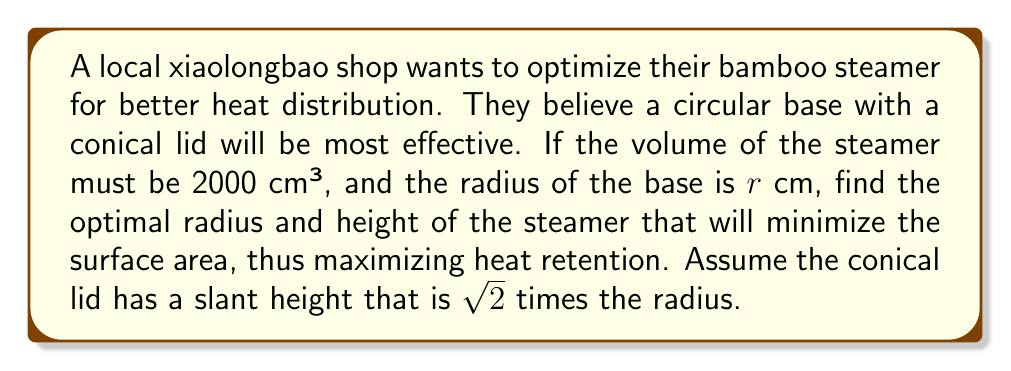Provide a solution to this math problem. Let's approach this step-by-step:

1) Let's define our variables:
   $r$ = radius of the base (and top of cone)
   $h$ = height of the cylindrical part
   $H$ = height of the cone

2) The volume of the steamer is the sum of the cylinder and cone volumes:
   $$V = \pi r^2 h + \frac{1}{3}\pi r^2 H = 2000$$

3) We're told the slant height of the cone is $\sqrt{2}r$. Using the Pythagorean theorem:
   $$r^2 + H^2 = 2r^2$$
   $$H = r$$

4) Substituting this into our volume equation:
   $$\pi r^2 h + \frac{1}{3}\pi r^3 = 2000$$
   $$\pi r^2 (h + \frac{1}{3}r) = 2000$$
   $$h = \frac{2000}{\pi r^2} - \frac{1}{3}r$$

5) The surface area (SA) of the steamer is the sum of the circular base, cylindrical side, and conical surface:
   $$SA = \pi r^2 + 2\pi rh + \pi r\sqrt{2}r$$
   
   Substituting $h$:
   $$SA = \pi r^2 + 2\pi r(\frac{2000}{\pi r^2} - \frac{1}{3}r) + \sqrt{2}\pi r^2$$
   $$SA = \pi r^2 + \frac{4000}{r} - \frac{2}{3}\pi r^2 + \sqrt{2}\pi r^2$$
   $$SA = (1 + \sqrt{2} - \frac{2}{3})\pi r^2 + \frac{4000}{r}$$

6) To minimize SA, we differentiate with respect to $r$ and set to zero:
   $$\frac{d(SA)}{dr} = 2(1 + \sqrt{2} - \frac{2}{3})\pi r - \frac{4000}{r^2} = 0$$
   
7) Solving this equation:
   $$(2 + 2\sqrt{2} - \frac{4}{3})\pi r^3 = 4000$$
   $$r = \sqrt[3]{\frac{4000}{(2 + 2\sqrt{2} - \frac{4}{3})\pi}} \approx 8.86 \text{ cm}$$

8) We can find $h$ by substituting this value of $r$ back into the equation from step 4.
Answer: The optimal radius is approximately 8.86 cm, and the optimal height of the cylindrical part is approximately 5.91 cm. The total height of the steamer (including the conical lid) is approximately 14.77 cm. 